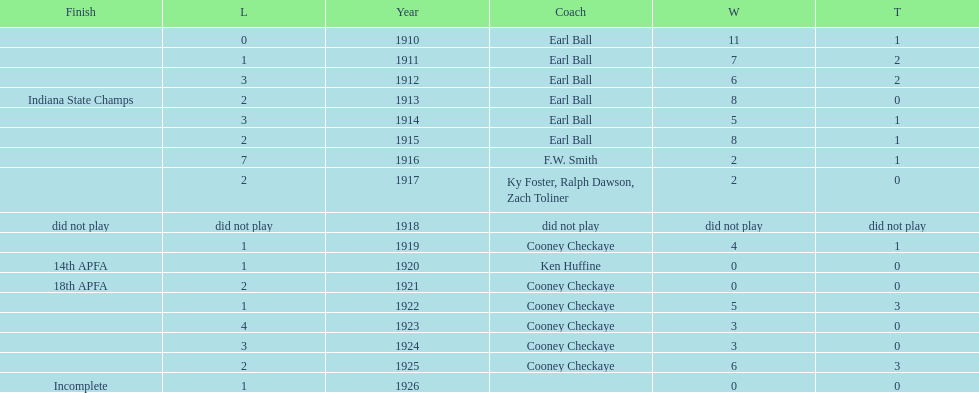Who coached the muncie flyers to an indiana state championship? Earl Ball. 